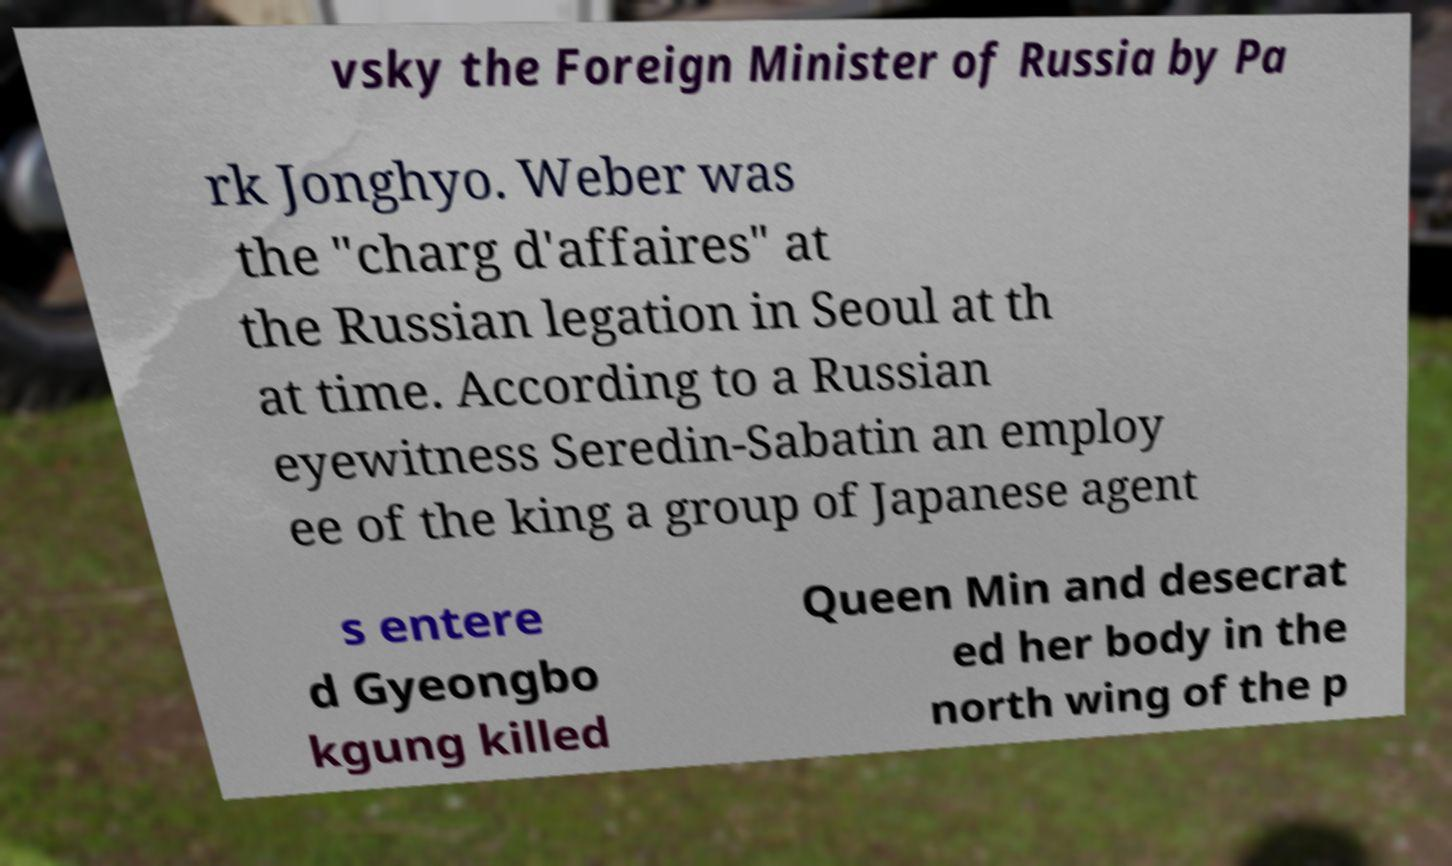Can you accurately transcribe the text from the provided image for me? vsky the Foreign Minister of Russia by Pa rk Jonghyo. Weber was the "charg d'affaires" at the Russian legation in Seoul at th at time. According to a Russian eyewitness Seredin-Sabatin an employ ee of the king a group of Japanese agent s entere d Gyeongbo kgung killed Queen Min and desecrat ed her body in the north wing of the p 